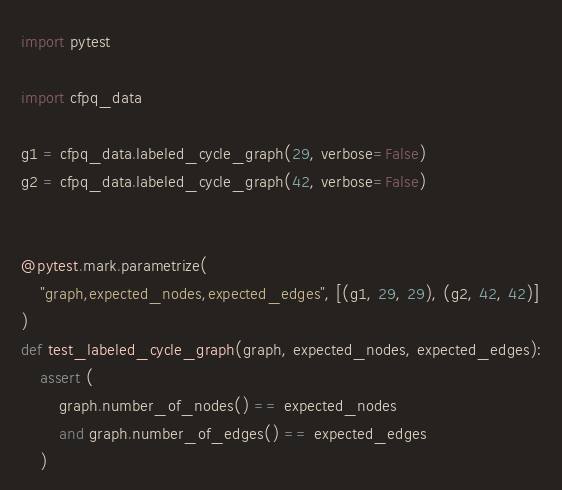<code> <loc_0><loc_0><loc_500><loc_500><_Python_>import pytest

import cfpq_data

g1 = cfpq_data.labeled_cycle_graph(29, verbose=False)
g2 = cfpq_data.labeled_cycle_graph(42, verbose=False)


@pytest.mark.parametrize(
    "graph,expected_nodes,expected_edges", [(g1, 29, 29), (g2, 42, 42)]
)
def test_labeled_cycle_graph(graph, expected_nodes, expected_edges):
    assert (
        graph.number_of_nodes() == expected_nodes
        and graph.number_of_edges() == expected_edges
    )
</code> 